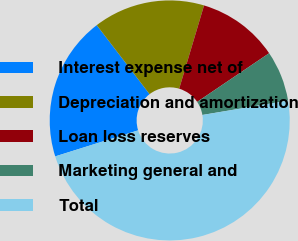Convert chart to OTSL. <chart><loc_0><loc_0><loc_500><loc_500><pie_chart><fcel>Interest expense net of<fcel>Depreciation and amortization<fcel>Loan loss reserves<fcel>Marketing general and<fcel>Total<nl><fcel>19.44%<fcel>15.02%<fcel>10.92%<fcel>6.82%<fcel>47.8%<nl></chart> 